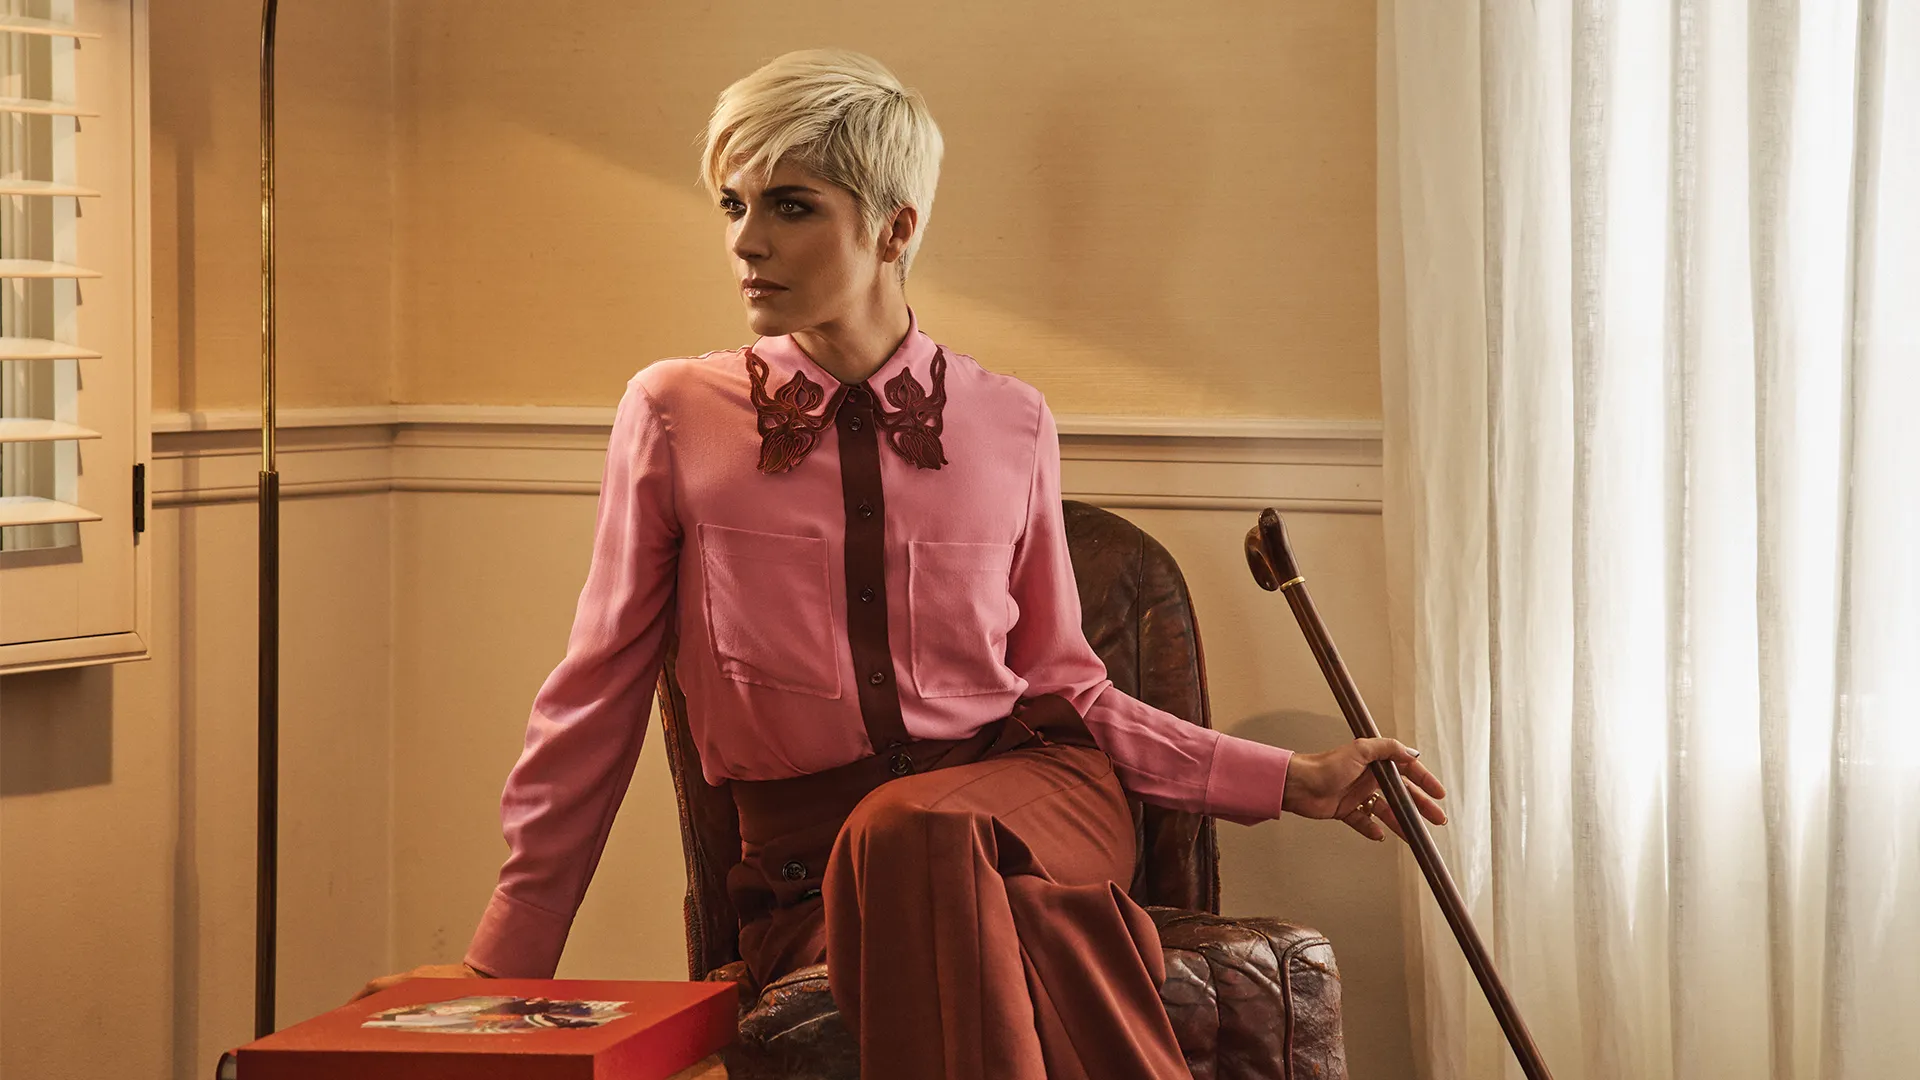What could the woman be planning to do next? The woman could be planning her next lecture on resilience and art, ready to inspire her students with her life stories. She might also be preparing to open the red box, filled with letters and keepsakes, and relive some cherished memories. Alternatively, she could be planning a quiet evening of self-reflection, contemplating her journey and future endeavors while drawing strength and comfort from her surroundings. Describe her immediate actions succinctly. She rests her hand on the red box, takes a deep breath, and shifts her gaze out of the window, lost in thought. 